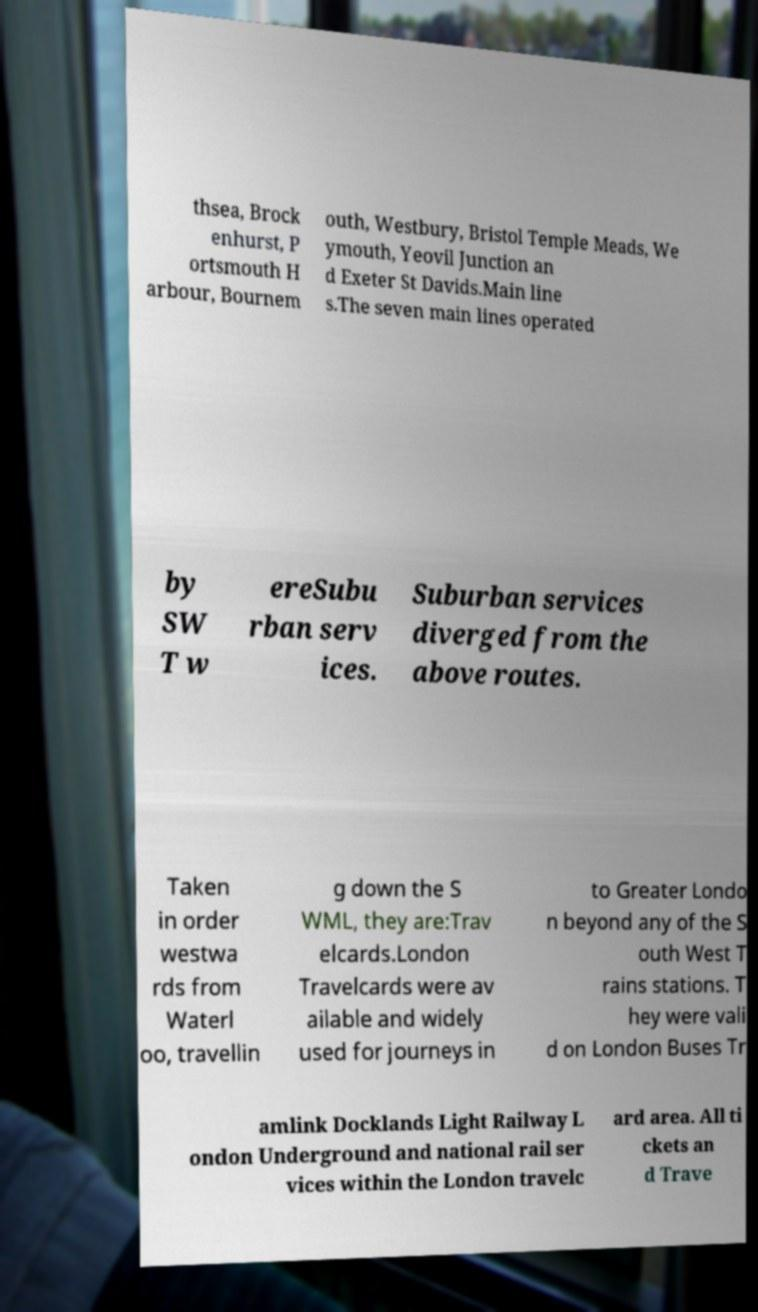For documentation purposes, I need the text within this image transcribed. Could you provide that? thsea, Brock enhurst, P ortsmouth H arbour, Bournem outh, Westbury, Bristol Temple Meads, We ymouth, Yeovil Junction an d Exeter St Davids.Main line s.The seven main lines operated by SW T w ereSubu rban serv ices. Suburban services diverged from the above routes. Taken in order westwa rds from Waterl oo, travellin g down the S WML, they are:Trav elcards.London Travelcards were av ailable and widely used for journeys in to Greater Londo n beyond any of the S outh West T rains stations. T hey were vali d on London Buses Tr amlink Docklands Light Railway L ondon Underground and national rail ser vices within the London travelc ard area. All ti ckets an d Trave 